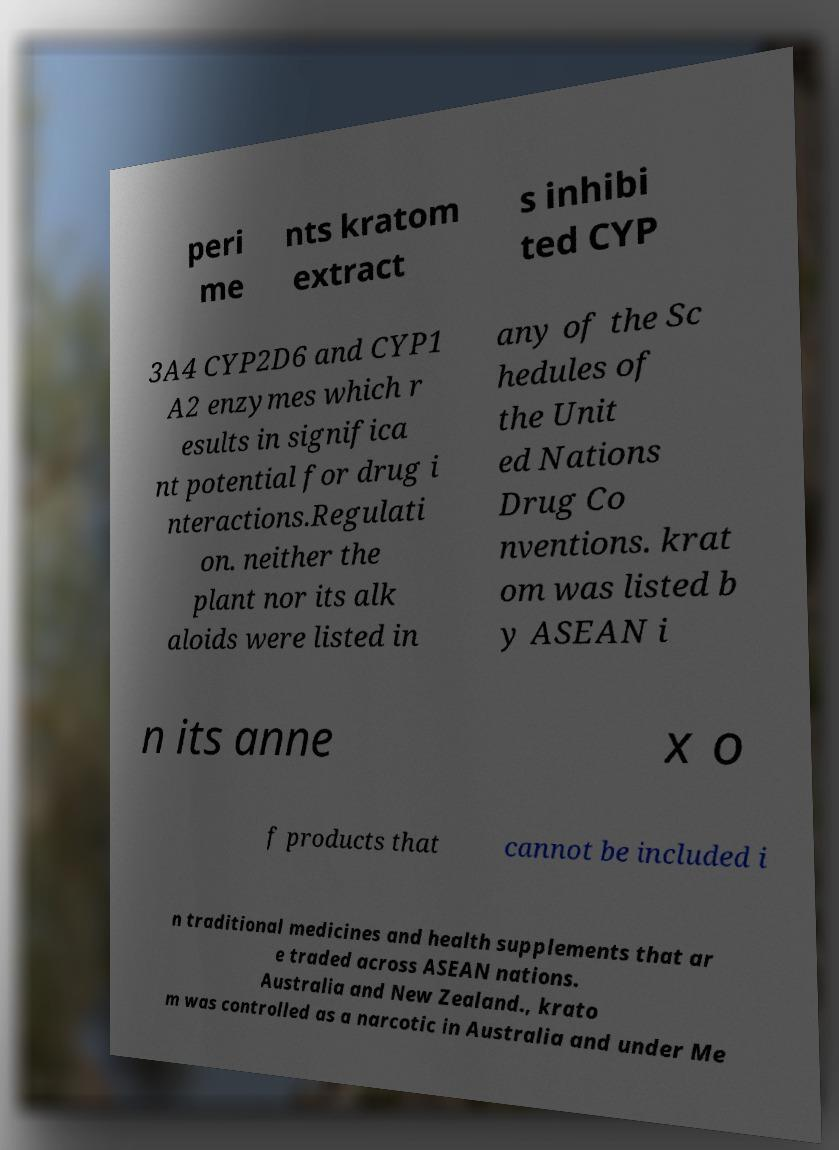Please read and relay the text visible in this image. What does it say? peri me nts kratom extract s inhibi ted CYP 3A4 CYP2D6 and CYP1 A2 enzymes which r esults in significa nt potential for drug i nteractions.Regulati on. neither the plant nor its alk aloids were listed in any of the Sc hedules of the Unit ed Nations Drug Co nventions. krat om was listed b y ASEAN i n its anne x o f products that cannot be included i n traditional medicines and health supplements that ar e traded across ASEAN nations. Australia and New Zealand., krato m was controlled as a narcotic in Australia and under Me 